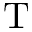Convert formula to latex. <formula><loc_0><loc_0><loc_500><loc_500>T</formula> 